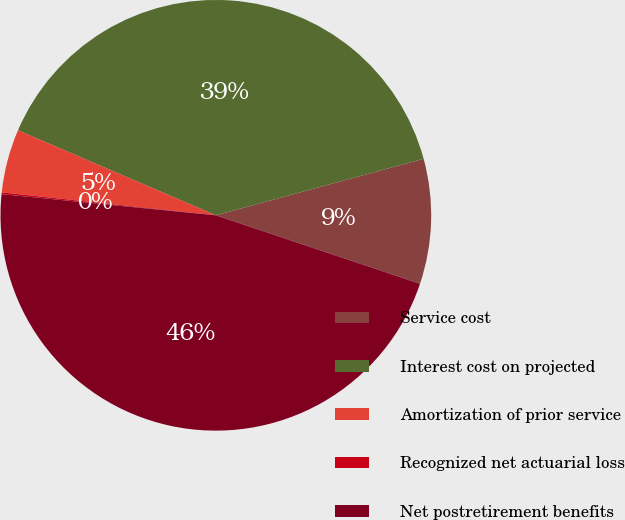Convert chart to OTSL. <chart><loc_0><loc_0><loc_500><loc_500><pie_chart><fcel>Service cost<fcel>Interest cost on projected<fcel>Amortization of prior service<fcel>Recognized net actuarial loss<fcel>Net postretirement benefits<nl><fcel>9.38%<fcel>39.32%<fcel>4.76%<fcel>0.13%<fcel>46.42%<nl></chart> 